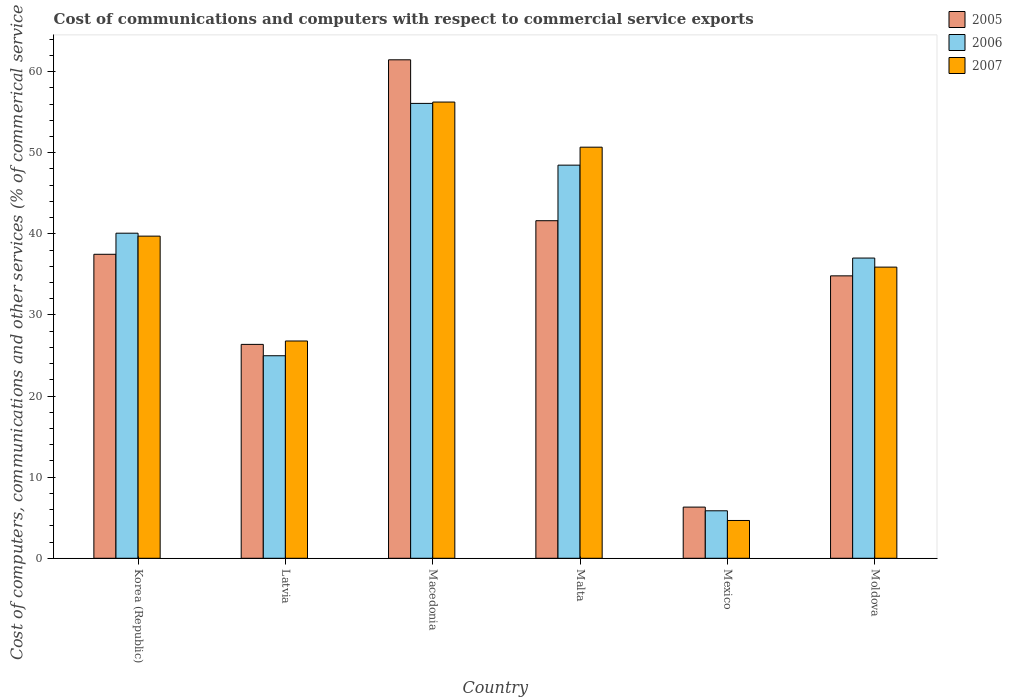How many different coloured bars are there?
Provide a short and direct response. 3. Are the number of bars per tick equal to the number of legend labels?
Keep it short and to the point. Yes. What is the label of the 2nd group of bars from the left?
Offer a terse response. Latvia. What is the cost of communications and computers in 2005 in Mexico?
Provide a short and direct response. 6.31. Across all countries, what is the maximum cost of communications and computers in 2006?
Offer a very short reply. 56.09. Across all countries, what is the minimum cost of communications and computers in 2005?
Your answer should be compact. 6.31. In which country was the cost of communications and computers in 2005 maximum?
Ensure brevity in your answer.  Macedonia. In which country was the cost of communications and computers in 2005 minimum?
Make the answer very short. Mexico. What is the total cost of communications and computers in 2006 in the graph?
Your response must be concise. 212.49. What is the difference between the cost of communications and computers in 2007 in Korea (Republic) and that in Latvia?
Ensure brevity in your answer.  12.93. What is the difference between the cost of communications and computers in 2005 in Malta and the cost of communications and computers in 2006 in Moldova?
Provide a succinct answer. 4.61. What is the average cost of communications and computers in 2007 per country?
Provide a short and direct response. 35.67. What is the difference between the cost of communications and computers of/in 2006 and cost of communications and computers of/in 2005 in Mexico?
Provide a succinct answer. -0.45. What is the ratio of the cost of communications and computers in 2007 in Korea (Republic) to that in Malta?
Your response must be concise. 0.78. What is the difference between the highest and the second highest cost of communications and computers in 2005?
Provide a succinct answer. 4.14. What is the difference between the highest and the lowest cost of communications and computers in 2007?
Provide a succinct answer. 51.59. What does the 2nd bar from the left in Malta represents?
Offer a very short reply. 2006. What does the 1st bar from the right in Malta represents?
Keep it short and to the point. 2007. Are all the bars in the graph horizontal?
Give a very brief answer. No. How many countries are there in the graph?
Your answer should be compact. 6. What is the difference between two consecutive major ticks on the Y-axis?
Offer a terse response. 10. Does the graph contain grids?
Your answer should be compact. No. What is the title of the graph?
Your response must be concise. Cost of communications and computers with respect to commercial service exports. Does "2006" appear as one of the legend labels in the graph?
Provide a short and direct response. Yes. What is the label or title of the Y-axis?
Provide a succinct answer. Cost of computers, communications and other services (% of commerical service exports). What is the Cost of computers, communications and other services (% of commerical service exports) of 2005 in Korea (Republic)?
Ensure brevity in your answer.  37.48. What is the Cost of computers, communications and other services (% of commerical service exports) in 2006 in Korea (Republic)?
Your response must be concise. 40.08. What is the Cost of computers, communications and other services (% of commerical service exports) of 2007 in Korea (Republic)?
Keep it short and to the point. 39.72. What is the Cost of computers, communications and other services (% of commerical service exports) in 2005 in Latvia?
Offer a terse response. 26.37. What is the Cost of computers, communications and other services (% of commerical service exports) of 2006 in Latvia?
Make the answer very short. 24.97. What is the Cost of computers, communications and other services (% of commerical service exports) in 2007 in Latvia?
Provide a succinct answer. 26.79. What is the Cost of computers, communications and other services (% of commerical service exports) of 2005 in Macedonia?
Ensure brevity in your answer.  61.46. What is the Cost of computers, communications and other services (% of commerical service exports) of 2006 in Macedonia?
Provide a succinct answer. 56.09. What is the Cost of computers, communications and other services (% of commerical service exports) in 2007 in Macedonia?
Offer a very short reply. 56.25. What is the Cost of computers, communications and other services (% of commerical service exports) of 2005 in Malta?
Make the answer very short. 41.62. What is the Cost of computers, communications and other services (% of commerical service exports) in 2006 in Malta?
Your response must be concise. 48.47. What is the Cost of computers, communications and other services (% of commerical service exports) in 2007 in Malta?
Your response must be concise. 50.69. What is the Cost of computers, communications and other services (% of commerical service exports) of 2005 in Mexico?
Your answer should be compact. 6.31. What is the Cost of computers, communications and other services (% of commerical service exports) in 2006 in Mexico?
Provide a short and direct response. 5.85. What is the Cost of computers, communications and other services (% of commerical service exports) in 2007 in Mexico?
Your answer should be compact. 4.66. What is the Cost of computers, communications and other services (% of commerical service exports) of 2005 in Moldova?
Offer a very short reply. 34.82. What is the Cost of computers, communications and other services (% of commerical service exports) of 2006 in Moldova?
Your answer should be compact. 37.02. What is the Cost of computers, communications and other services (% of commerical service exports) of 2007 in Moldova?
Ensure brevity in your answer.  35.9. Across all countries, what is the maximum Cost of computers, communications and other services (% of commerical service exports) of 2005?
Your answer should be compact. 61.46. Across all countries, what is the maximum Cost of computers, communications and other services (% of commerical service exports) of 2006?
Your answer should be compact. 56.09. Across all countries, what is the maximum Cost of computers, communications and other services (% of commerical service exports) of 2007?
Provide a short and direct response. 56.25. Across all countries, what is the minimum Cost of computers, communications and other services (% of commerical service exports) in 2005?
Ensure brevity in your answer.  6.31. Across all countries, what is the minimum Cost of computers, communications and other services (% of commerical service exports) of 2006?
Provide a succinct answer. 5.85. Across all countries, what is the minimum Cost of computers, communications and other services (% of commerical service exports) in 2007?
Your response must be concise. 4.66. What is the total Cost of computers, communications and other services (% of commerical service exports) in 2005 in the graph?
Give a very brief answer. 208.07. What is the total Cost of computers, communications and other services (% of commerical service exports) in 2006 in the graph?
Provide a short and direct response. 212.49. What is the total Cost of computers, communications and other services (% of commerical service exports) in 2007 in the graph?
Provide a succinct answer. 214.01. What is the difference between the Cost of computers, communications and other services (% of commerical service exports) of 2005 in Korea (Republic) and that in Latvia?
Your answer should be compact. 11.11. What is the difference between the Cost of computers, communications and other services (% of commerical service exports) of 2006 in Korea (Republic) and that in Latvia?
Your response must be concise. 15.11. What is the difference between the Cost of computers, communications and other services (% of commerical service exports) in 2007 in Korea (Republic) and that in Latvia?
Provide a short and direct response. 12.93. What is the difference between the Cost of computers, communications and other services (% of commerical service exports) in 2005 in Korea (Republic) and that in Macedonia?
Ensure brevity in your answer.  -23.98. What is the difference between the Cost of computers, communications and other services (% of commerical service exports) of 2006 in Korea (Republic) and that in Macedonia?
Your answer should be compact. -16. What is the difference between the Cost of computers, communications and other services (% of commerical service exports) in 2007 in Korea (Republic) and that in Macedonia?
Offer a terse response. -16.53. What is the difference between the Cost of computers, communications and other services (% of commerical service exports) in 2005 in Korea (Republic) and that in Malta?
Provide a short and direct response. -4.14. What is the difference between the Cost of computers, communications and other services (% of commerical service exports) of 2006 in Korea (Republic) and that in Malta?
Ensure brevity in your answer.  -8.39. What is the difference between the Cost of computers, communications and other services (% of commerical service exports) of 2007 in Korea (Republic) and that in Malta?
Give a very brief answer. -10.97. What is the difference between the Cost of computers, communications and other services (% of commerical service exports) of 2005 in Korea (Republic) and that in Mexico?
Provide a short and direct response. 31.17. What is the difference between the Cost of computers, communications and other services (% of commerical service exports) in 2006 in Korea (Republic) and that in Mexico?
Provide a succinct answer. 34.23. What is the difference between the Cost of computers, communications and other services (% of commerical service exports) of 2007 in Korea (Republic) and that in Mexico?
Offer a very short reply. 35.06. What is the difference between the Cost of computers, communications and other services (% of commerical service exports) of 2005 in Korea (Republic) and that in Moldova?
Ensure brevity in your answer.  2.66. What is the difference between the Cost of computers, communications and other services (% of commerical service exports) of 2006 in Korea (Republic) and that in Moldova?
Offer a terse response. 3.06. What is the difference between the Cost of computers, communications and other services (% of commerical service exports) of 2007 in Korea (Republic) and that in Moldova?
Your response must be concise. 3.82. What is the difference between the Cost of computers, communications and other services (% of commerical service exports) of 2005 in Latvia and that in Macedonia?
Make the answer very short. -35.09. What is the difference between the Cost of computers, communications and other services (% of commerical service exports) of 2006 in Latvia and that in Macedonia?
Your answer should be very brief. -31.11. What is the difference between the Cost of computers, communications and other services (% of commerical service exports) of 2007 in Latvia and that in Macedonia?
Provide a short and direct response. -29.46. What is the difference between the Cost of computers, communications and other services (% of commerical service exports) in 2005 in Latvia and that in Malta?
Provide a short and direct response. -15.25. What is the difference between the Cost of computers, communications and other services (% of commerical service exports) of 2006 in Latvia and that in Malta?
Offer a very short reply. -23.5. What is the difference between the Cost of computers, communications and other services (% of commerical service exports) of 2007 in Latvia and that in Malta?
Give a very brief answer. -23.9. What is the difference between the Cost of computers, communications and other services (% of commerical service exports) of 2005 in Latvia and that in Mexico?
Your answer should be very brief. 20.06. What is the difference between the Cost of computers, communications and other services (% of commerical service exports) in 2006 in Latvia and that in Mexico?
Give a very brief answer. 19.12. What is the difference between the Cost of computers, communications and other services (% of commerical service exports) in 2007 in Latvia and that in Mexico?
Provide a short and direct response. 22.13. What is the difference between the Cost of computers, communications and other services (% of commerical service exports) of 2005 in Latvia and that in Moldova?
Ensure brevity in your answer.  -8.45. What is the difference between the Cost of computers, communications and other services (% of commerical service exports) of 2006 in Latvia and that in Moldova?
Keep it short and to the point. -12.04. What is the difference between the Cost of computers, communications and other services (% of commerical service exports) in 2007 in Latvia and that in Moldova?
Your answer should be very brief. -9.11. What is the difference between the Cost of computers, communications and other services (% of commerical service exports) in 2005 in Macedonia and that in Malta?
Provide a succinct answer. 19.84. What is the difference between the Cost of computers, communications and other services (% of commerical service exports) of 2006 in Macedonia and that in Malta?
Your answer should be compact. 7.61. What is the difference between the Cost of computers, communications and other services (% of commerical service exports) of 2007 in Macedonia and that in Malta?
Ensure brevity in your answer.  5.56. What is the difference between the Cost of computers, communications and other services (% of commerical service exports) in 2005 in Macedonia and that in Mexico?
Keep it short and to the point. 55.15. What is the difference between the Cost of computers, communications and other services (% of commerical service exports) in 2006 in Macedonia and that in Mexico?
Your answer should be compact. 50.23. What is the difference between the Cost of computers, communications and other services (% of commerical service exports) of 2007 in Macedonia and that in Mexico?
Your response must be concise. 51.59. What is the difference between the Cost of computers, communications and other services (% of commerical service exports) of 2005 in Macedonia and that in Moldova?
Ensure brevity in your answer.  26.64. What is the difference between the Cost of computers, communications and other services (% of commerical service exports) in 2006 in Macedonia and that in Moldova?
Your answer should be compact. 19.07. What is the difference between the Cost of computers, communications and other services (% of commerical service exports) of 2007 in Macedonia and that in Moldova?
Your answer should be very brief. 20.35. What is the difference between the Cost of computers, communications and other services (% of commerical service exports) of 2005 in Malta and that in Mexico?
Keep it short and to the point. 35.31. What is the difference between the Cost of computers, communications and other services (% of commerical service exports) of 2006 in Malta and that in Mexico?
Ensure brevity in your answer.  42.62. What is the difference between the Cost of computers, communications and other services (% of commerical service exports) in 2007 in Malta and that in Mexico?
Make the answer very short. 46.03. What is the difference between the Cost of computers, communications and other services (% of commerical service exports) of 2005 in Malta and that in Moldova?
Provide a short and direct response. 6.8. What is the difference between the Cost of computers, communications and other services (% of commerical service exports) in 2006 in Malta and that in Moldova?
Your answer should be compact. 11.46. What is the difference between the Cost of computers, communications and other services (% of commerical service exports) of 2007 in Malta and that in Moldova?
Make the answer very short. 14.79. What is the difference between the Cost of computers, communications and other services (% of commerical service exports) of 2005 in Mexico and that in Moldova?
Your response must be concise. -28.51. What is the difference between the Cost of computers, communications and other services (% of commerical service exports) in 2006 in Mexico and that in Moldova?
Provide a succinct answer. -31.16. What is the difference between the Cost of computers, communications and other services (% of commerical service exports) of 2007 in Mexico and that in Moldova?
Give a very brief answer. -31.24. What is the difference between the Cost of computers, communications and other services (% of commerical service exports) of 2005 in Korea (Republic) and the Cost of computers, communications and other services (% of commerical service exports) of 2006 in Latvia?
Your answer should be compact. 12.51. What is the difference between the Cost of computers, communications and other services (% of commerical service exports) in 2005 in Korea (Republic) and the Cost of computers, communications and other services (% of commerical service exports) in 2007 in Latvia?
Give a very brief answer. 10.69. What is the difference between the Cost of computers, communications and other services (% of commerical service exports) of 2006 in Korea (Republic) and the Cost of computers, communications and other services (% of commerical service exports) of 2007 in Latvia?
Offer a terse response. 13.29. What is the difference between the Cost of computers, communications and other services (% of commerical service exports) of 2005 in Korea (Republic) and the Cost of computers, communications and other services (% of commerical service exports) of 2006 in Macedonia?
Offer a terse response. -18.6. What is the difference between the Cost of computers, communications and other services (% of commerical service exports) in 2005 in Korea (Republic) and the Cost of computers, communications and other services (% of commerical service exports) in 2007 in Macedonia?
Provide a succinct answer. -18.77. What is the difference between the Cost of computers, communications and other services (% of commerical service exports) in 2006 in Korea (Republic) and the Cost of computers, communications and other services (% of commerical service exports) in 2007 in Macedonia?
Offer a very short reply. -16.17. What is the difference between the Cost of computers, communications and other services (% of commerical service exports) in 2005 in Korea (Republic) and the Cost of computers, communications and other services (% of commerical service exports) in 2006 in Malta?
Your answer should be very brief. -10.99. What is the difference between the Cost of computers, communications and other services (% of commerical service exports) of 2005 in Korea (Republic) and the Cost of computers, communications and other services (% of commerical service exports) of 2007 in Malta?
Offer a terse response. -13.21. What is the difference between the Cost of computers, communications and other services (% of commerical service exports) of 2006 in Korea (Republic) and the Cost of computers, communications and other services (% of commerical service exports) of 2007 in Malta?
Provide a short and direct response. -10.61. What is the difference between the Cost of computers, communications and other services (% of commerical service exports) of 2005 in Korea (Republic) and the Cost of computers, communications and other services (% of commerical service exports) of 2006 in Mexico?
Provide a succinct answer. 31.63. What is the difference between the Cost of computers, communications and other services (% of commerical service exports) in 2005 in Korea (Republic) and the Cost of computers, communications and other services (% of commerical service exports) in 2007 in Mexico?
Keep it short and to the point. 32.82. What is the difference between the Cost of computers, communications and other services (% of commerical service exports) in 2006 in Korea (Republic) and the Cost of computers, communications and other services (% of commerical service exports) in 2007 in Mexico?
Make the answer very short. 35.42. What is the difference between the Cost of computers, communications and other services (% of commerical service exports) of 2005 in Korea (Republic) and the Cost of computers, communications and other services (% of commerical service exports) of 2006 in Moldova?
Provide a succinct answer. 0.46. What is the difference between the Cost of computers, communications and other services (% of commerical service exports) of 2005 in Korea (Republic) and the Cost of computers, communications and other services (% of commerical service exports) of 2007 in Moldova?
Your response must be concise. 1.58. What is the difference between the Cost of computers, communications and other services (% of commerical service exports) of 2006 in Korea (Republic) and the Cost of computers, communications and other services (% of commerical service exports) of 2007 in Moldova?
Your response must be concise. 4.18. What is the difference between the Cost of computers, communications and other services (% of commerical service exports) of 2005 in Latvia and the Cost of computers, communications and other services (% of commerical service exports) of 2006 in Macedonia?
Offer a very short reply. -29.71. What is the difference between the Cost of computers, communications and other services (% of commerical service exports) of 2005 in Latvia and the Cost of computers, communications and other services (% of commerical service exports) of 2007 in Macedonia?
Make the answer very short. -29.88. What is the difference between the Cost of computers, communications and other services (% of commerical service exports) in 2006 in Latvia and the Cost of computers, communications and other services (% of commerical service exports) in 2007 in Macedonia?
Keep it short and to the point. -31.28. What is the difference between the Cost of computers, communications and other services (% of commerical service exports) of 2005 in Latvia and the Cost of computers, communications and other services (% of commerical service exports) of 2006 in Malta?
Ensure brevity in your answer.  -22.1. What is the difference between the Cost of computers, communications and other services (% of commerical service exports) of 2005 in Latvia and the Cost of computers, communications and other services (% of commerical service exports) of 2007 in Malta?
Your answer should be compact. -24.32. What is the difference between the Cost of computers, communications and other services (% of commerical service exports) in 2006 in Latvia and the Cost of computers, communications and other services (% of commerical service exports) in 2007 in Malta?
Give a very brief answer. -25.71. What is the difference between the Cost of computers, communications and other services (% of commerical service exports) in 2005 in Latvia and the Cost of computers, communications and other services (% of commerical service exports) in 2006 in Mexico?
Offer a very short reply. 20.52. What is the difference between the Cost of computers, communications and other services (% of commerical service exports) in 2005 in Latvia and the Cost of computers, communications and other services (% of commerical service exports) in 2007 in Mexico?
Ensure brevity in your answer.  21.71. What is the difference between the Cost of computers, communications and other services (% of commerical service exports) of 2006 in Latvia and the Cost of computers, communications and other services (% of commerical service exports) of 2007 in Mexico?
Make the answer very short. 20.31. What is the difference between the Cost of computers, communications and other services (% of commerical service exports) in 2005 in Latvia and the Cost of computers, communications and other services (% of commerical service exports) in 2006 in Moldova?
Offer a terse response. -10.65. What is the difference between the Cost of computers, communications and other services (% of commerical service exports) of 2005 in Latvia and the Cost of computers, communications and other services (% of commerical service exports) of 2007 in Moldova?
Give a very brief answer. -9.53. What is the difference between the Cost of computers, communications and other services (% of commerical service exports) of 2006 in Latvia and the Cost of computers, communications and other services (% of commerical service exports) of 2007 in Moldova?
Keep it short and to the point. -10.93. What is the difference between the Cost of computers, communications and other services (% of commerical service exports) in 2005 in Macedonia and the Cost of computers, communications and other services (% of commerical service exports) in 2006 in Malta?
Your response must be concise. 12.99. What is the difference between the Cost of computers, communications and other services (% of commerical service exports) of 2005 in Macedonia and the Cost of computers, communications and other services (% of commerical service exports) of 2007 in Malta?
Your answer should be compact. 10.78. What is the difference between the Cost of computers, communications and other services (% of commerical service exports) in 2006 in Macedonia and the Cost of computers, communications and other services (% of commerical service exports) in 2007 in Malta?
Your response must be concise. 5.4. What is the difference between the Cost of computers, communications and other services (% of commerical service exports) in 2005 in Macedonia and the Cost of computers, communications and other services (% of commerical service exports) in 2006 in Mexico?
Offer a very short reply. 55.61. What is the difference between the Cost of computers, communications and other services (% of commerical service exports) in 2005 in Macedonia and the Cost of computers, communications and other services (% of commerical service exports) in 2007 in Mexico?
Ensure brevity in your answer.  56.8. What is the difference between the Cost of computers, communications and other services (% of commerical service exports) of 2006 in Macedonia and the Cost of computers, communications and other services (% of commerical service exports) of 2007 in Mexico?
Provide a succinct answer. 51.43. What is the difference between the Cost of computers, communications and other services (% of commerical service exports) of 2005 in Macedonia and the Cost of computers, communications and other services (% of commerical service exports) of 2006 in Moldova?
Provide a short and direct response. 24.45. What is the difference between the Cost of computers, communications and other services (% of commerical service exports) in 2005 in Macedonia and the Cost of computers, communications and other services (% of commerical service exports) in 2007 in Moldova?
Your answer should be very brief. 25.56. What is the difference between the Cost of computers, communications and other services (% of commerical service exports) of 2006 in Macedonia and the Cost of computers, communications and other services (% of commerical service exports) of 2007 in Moldova?
Ensure brevity in your answer.  20.19. What is the difference between the Cost of computers, communications and other services (% of commerical service exports) of 2005 in Malta and the Cost of computers, communications and other services (% of commerical service exports) of 2006 in Mexico?
Offer a very short reply. 35.77. What is the difference between the Cost of computers, communications and other services (% of commerical service exports) in 2005 in Malta and the Cost of computers, communications and other services (% of commerical service exports) in 2007 in Mexico?
Make the answer very short. 36.96. What is the difference between the Cost of computers, communications and other services (% of commerical service exports) of 2006 in Malta and the Cost of computers, communications and other services (% of commerical service exports) of 2007 in Mexico?
Give a very brief answer. 43.81. What is the difference between the Cost of computers, communications and other services (% of commerical service exports) in 2005 in Malta and the Cost of computers, communications and other services (% of commerical service exports) in 2006 in Moldova?
Keep it short and to the point. 4.61. What is the difference between the Cost of computers, communications and other services (% of commerical service exports) in 2005 in Malta and the Cost of computers, communications and other services (% of commerical service exports) in 2007 in Moldova?
Make the answer very short. 5.72. What is the difference between the Cost of computers, communications and other services (% of commerical service exports) of 2006 in Malta and the Cost of computers, communications and other services (% of commerical service exports) of 2007 in Moldova?
Offer a terse response. 12.57. What is the difference between the Cost of computers, communications and other services (% of commerical service exports) of 2005 in Mexico and the Cost of computers, communications and other services (% of commerical service exports) of 2006 in Moldova?
Your response must be concise. -30.71. What is the difference between the Cost of computers, communications and other services (% of commerical service exports) of 2005 in Mexico and the Cost of computers, communications and other services (% of commerical service exports) of 2007 in Moldova?
Offer a very short reply. -29.59. What is the difference between the Cost of computers, communications and other services (% of commerical service exports) of 2006 in Mexico and the Cost of computers, communications and other services (% of commerical service exports) of 2007 in Moldova?
Offer a terse response. -30.04. What is the average Cost of computers, communications and other services (% of commerical service exports) of 2005 per country?
Offer a terse response. 34.68. What is the average Cost of computers, communications and other services (% of commerical service exports) in 2006 per country?
Your answer should be very brief. 35.41. What is the average Cost of computers, communications and other services (% of commerical service exports) in 2007 per country?
Offer a very short reply. 35.67. What is the difference between the Cost of computers, communications and other services (% of commerical service exports) in 2005 and Cost of computers, communications and other services (% of commerical service exports) in 2006 in Korea (Republic)?
Your answer should be compact. -2.6. What is the difference between the Cost of computers, communications and other services (% of commerical service exports) in 2005 and Cost of computers, communications and other services (% of commerical service exports) in 2007 in Korea (Republic)?
Keep it short and to the point. -2.24. What is the difference between the Cost of computers, communications and other services (% of commerical service exports) in 2006 and Cost of computers, communications and other services (% of commerical service exports) in 2007 in Korea (Republic)?
Provide a short and direct response. 0.36. What is the difference between the Cost of computers, communications and other services (% of commerical service exports) of 2005 and Cost of computers, communications and other services (% of commerical service exports) of 2006 in Latvia?
Offer a terse response. 1.4. What is the difference between the Cost of computers, communications and other services (% of commerical service exports) in 2005 and Cost of computers, communications and other services (% of commerical service exports) in 2007 in Latvia?
Your answer should be very brief. -0.42. What is the difference between the Cost of computers, communications and other services (% of commerical service exports) of 2006 and Cost of computers, communications and other services (% of commerical service exports) of 2007 in Latvia?
Offer a terse response. -1.82. What is the difference between the Cost of computers, communications and other services (% of commerical service exports) of 2005 and Cost of computers, communications and other services (% of commerical service exports) of 2006 in Macedonia?
Provide a short and direct response. 5.38. What is the difference between the Cost of computers, communications and other services (% of commerical service exports) in 2005 and Cost of computers, communications and other services (% of commerical service exports) in 2007 in Macedonia?
Offer a very short reply. 5.21. What is the difference between the Cost of computers, communications and other services (% of commerical service exports) in 2006 and Cost of computers, communications and other services (% of commerical service exports) in 2007 in Macedonia?
Give a very brief answer. -0.17. What is the difference between the Cost of computers, communications and other services (% of commerical service exports) of 2005 and Cost of computers, communications and other services (% of commerical service exports) of 2006 in Malta?
Give a very brief answer. -6.85. What is the difference between the Cost of computers, communications and other services (% of commerical service exports) in 2005 and Cost of computers, communications and other services (% of commerical service exports) in 2007 in Malta?
Your response must be concise. -9.07. What is the difference between the Cost of computers, communications and other services (% of commerical service exports) of 2006 and Cost of computers, communications and other services (% of commerical service exports) of 2007 in Malta?
Give a very brief answer. -2.21. What is the difference between the Cost of computers, communications and other services (% of commerical service exports) of 2005 and Cost of computers, communications and other services (% of commerical service exports) of 2006 in Mexico?
Give a very brief answer. 0.45. What is the difference between the Cost of computers, communications and other services (% of commerical service exports) of 2005 and Cost of computers, communications and other services (% of commerical service exports) of 2007 in Mexico?
Ensure brevity in your answer.  1.65. What is the difference between the Cost of computers, communications and other services (% of commerical service exports) of 2006 and Cost of computers, communications and other services (% of commerical service exports) of 2007 in Mexico?
Give a very brief answer. 1.19. What is the difference between the Cost of computers, communications and other services (% of commerical service exports) in 2005 and Cost of computers, communications and other services (% of commerical service exports) in 2006 in Moldova?
Ensure brevity in your answer.  -2.19. What is the difference between the Cost of computers, communications and other services (% of commerical service exports) in 2005 and Cost of computers, communications and other services (% of commerical service exports) in 2007 in Moldova?
Give a very brief answer. -1.08. What is the difference between the Cost of computers, communications and other services (% of commerical service exports) of 2006 and Cost of computers, communications and other services (% of commerical service exports) of 2007 in Moldova?
Offer a terse response. 1.12. What is the ratio of the Cost of computers, communications and other services (% of commerical service exports) in 2005 in Korea (Republic) to that in Latvia?
Your answer should be compact. 1.42. What is the ratio of the Cost of computers, communications and other services (% of commerical service exports) in 2006 in Korea (Republic) to that in Latvia?
Offer a very short reply. 1.6. What is the ratio of the Cost of computers, communications and other services (% of commerical service exports) of 2007 in Korea (Republic) to that in Latvia?
Keep it short and to the point. 1.48. What is the ratio of the Cost of computers, communications and other services (% of commerical service exports) in 2005 in Korea (Republic) to that in Macedonia?
Provide a short and direct response. 0.61. What is the ratio of the Cost of computers, communications and other services (% of commerical service exports) of 2006 in Korea (Republic) to that in Macedonia?
Offer a very short reply. 0.71. What is the ratio of the Cost of computers, communications and other services (% of commerical service exports) of 2007 in Korea (Republic) to that in Macedonia?
Keep it short and to the point. 0.71. What is the ratio of the Cost of computers, communications and other services (% of commerical service exports) in 2005 in Korea (Republic) to that in Malta?
Give a very brief answer. 0.9. What is the ratio of the Cost of computers, communications and other services (% of commerical service exports) in 2006 in Korea (Republic) to that in Malta?
Make the answer very short. 0.83. What is the ratio of the Cost of computers, communications and other services (% of commerical service exports) in 2007 in Korea (Republic) to that in Malta?
Give a very brief answer. 0.78. What is the ratio of the Cost of computers, communications and other services (% of commerical service exports) of 2005 in Korea (Republic) to that in Mexico?
Offer a terse response. 5.94. What is the ratio of the Cost of computers, communications and other services (% of commerical service exports) in 2006 in Korea (Republic) to that in Mexico?
Provide a succinct answer. 6.85. What is the ratio of the Cost of computers, communications and other services (% of commerical service exports) of 2007 in Korea (Republic) to that in Mexico?
Ensure brevity in your answer.  8.52. What is the ratio of the Cost of computers, communications and other services (% of commerical service exports) of 2005 in Korea (Republic) to that in Moldova?
Your response must be concise. 1.08. What is the ratio of the Cost of computers, communications and other services (% of commerical service exports) in 2006 in Korea (Republic) to that in Moldova?
Ensure brevity in your answer.  1.08. What is the ratio of the Cost of computers, communications and other services (% of commerical service exports) in 2007 in Korea (Republic) to that in Moldova?
Your response must be concise. 1.11. What is the ratio of the Cost of computers, communications and other services (% of commerical service exports) in 2005 in Latvia to that in Macedonia?
Keep it short and to the point. 0.43. What is the ratio of the Cost of computers, communications and other services (% of commerical service exports) in 2006 in Latvia to that in Macedonia?
Provide a succinct answer. 0.45. What is the ratio of the Cost of computers, communications and other services (% of commerical service exports) of 2007 in Latvia to that in Macedonia?
Ensure brevity in your answer.  0.48. What is the ratio of the Cost of computers, communications and other services (% of commerical service exports) in 2005 in Latvia to that in Malta?
Your response must be concise. 0.63. What is the ratio of the Cost of computers, communications and other services (% of commerical service exports) in 2006 in Latvia to that in Malta?
Ensure brevity in your answer.  0.52. What is the ratio of the Cost of computers, communications and other services (% of commerical service exports) of 2007 in Latvia to that in Malta?
Provide a succinct answer. 0.53. What is the ratio of the Cost of computers, communications and other services (% of commerical service exports) in 2005 in Latvia to that in Mexico?
Your answer should be compact. 4.18. What is the ratio of the Cost of computers, communications and other services (% of commerical service exports) in 2006 in Latvia to that in Mexico?
Offer a very short reply. 4.27. What is the ratio of the Cost of computers, communications and other services (% of commerical service exports) of 2007 in Latvia to that in Mexico?
Keep it short and to the point. 5.75. What is the ratio of the Cost of computers, communications and other services (% of commerical service exports) of 2005 in Latvia to that in Moldova?
Your answer should be very brief. 0.76. What is the ratio of the Cost of computers, communications and other services (% of commerical service exports) of 2006 in Latvia to that in Moldova?
Make the answer very short. 0.67. What is the ratio of the Cost of computers, communications and other services (% of commerical service exports) of 2007 in Latvia to that in Moldova?
Your answer should be compact. 0.75. What is the ratio of the Cost of computers, communications and other services (% of commerical service exports) of 2005 in Macedonia to that in Malta?
Keep it short and to the point. 1.48. What is the ratio of the Cost of computers, communications and other services (% of commerical service exports) in 2006 in Macedonia to that in Malta?
Your answer should be very brief. 1.16. What is the ratio of the Cost of computers, communications and other services (% of commerical service exports) of 2007 in Macedonia to that in Malta?
Keep it short and to the point. 1.11. What is the ratio of the Cost of computers, communications and other services (% of commerical service exports) in 2005 in Macedonia to that in Mexico?
Make the answer very short. 9.74. What is the ratio of the Cost of computers, communications and other services (% of commerical service exports) in 2006 in Macedonia to that in Mexico?
Provide a succinct answer. 9.58. What is the ratio of the Cost of computers, communications and other services (% of commerical service exports) of 2007 in Macedonia to that in Mexico?
Offer a very short reply. 12.07. What is the ratio of the Cost of computers, communications and other services (% of commerical service exports) in 2005 in Macedonia to that in Moldova?
Your answer should be very brief. 1.76. What is the ratio of the Cost of computers, communications and other services (% of commerical service exports) in 2006 in Macedonia to that in Moldova?
Keep it short and to the point. 1.52. What is the ratio of the Cost of computers, communications and other services (% of commerical service exports) in 2007 in Macedonia to that in Moldova?
Your response must be concise. 1.57. What is the ratio of the Cost of computers, communications and other services (% of commerical service exports) of 2005 in Malta to that in Mexico?
Your answer should be compact. 6.6. What is the ratio of the Cost of computers, communications and other services (% of commerical service exports) in 2006 in Malta to that in Mexico?
Your response must be concise. 8.28. What is the ratio of the Cost of computers, communications and other services (% of commerical service exports) in 2007 in Malta to that in Mexico?
Give a very brief answer. 10.88. What is the ratio of the Cost of computers, communications and other services (% of commerical service exports) in 2005 in Malta to that in Moldova?
Your response must be concise. 1.2. What is the ratio of the Cost of computers, communications and other services (% of commerical service exports) of 2006 in Malta to that in Moldova?
Make the answer very short. 1.31. What is the ratio of the Cost of computers, communications and other services (% of commerical service exports) in 2007 in Malta to that in Moldova?
Offer a very short reply. 1.41. What is the ratio of the Cost of computers, communications and other services (% of commerical service exports) in 2005 in Mexico to that in Moldova?
Give a very brief answer. 0.18. What is the ratio of the Cost of computers, communications and other services (% of commerical service exports) in 2006 in Mexico to that in Moldova?
Provide a succinct answer. 0.16. What is the ratio of the Cost of computers, communications and other services (% of commerical service exports) in 2007 in Mexico to that in Moldova?
Provide a short and direct response. 0.13. What is the difference between the highest and the second highest Cost of computers, communications and other services (% of commerical service exports) in 2005?
Keep it short and to the point. 19.84. What is the difference between the highest and the second highest Cost of computers, communications and other services (% of commerical service exports) in 2006?
Your answer should be very brief. 7.61. What is the difference between the highest and the second highest Cost of computers, communications and other services (% of commerical service exports) in 2007?
Ensure brevity in your answer.  5.56. What is the difference between the highest and the lowest Cost of computers, communications and other services (% of commerical service exports) of 2005?
Offer a very short reply. 55.15. What is the difference between the highest and the lowest Cost of computers, communications and other services (% of commerical service exports) in 2006?
Offer a terse response. 50.23. What is the difference between the highest and the lowest Cost of computers, communications and other services (% of commerical service exports) of 2007?
Give a very brief answer. 51.59. 